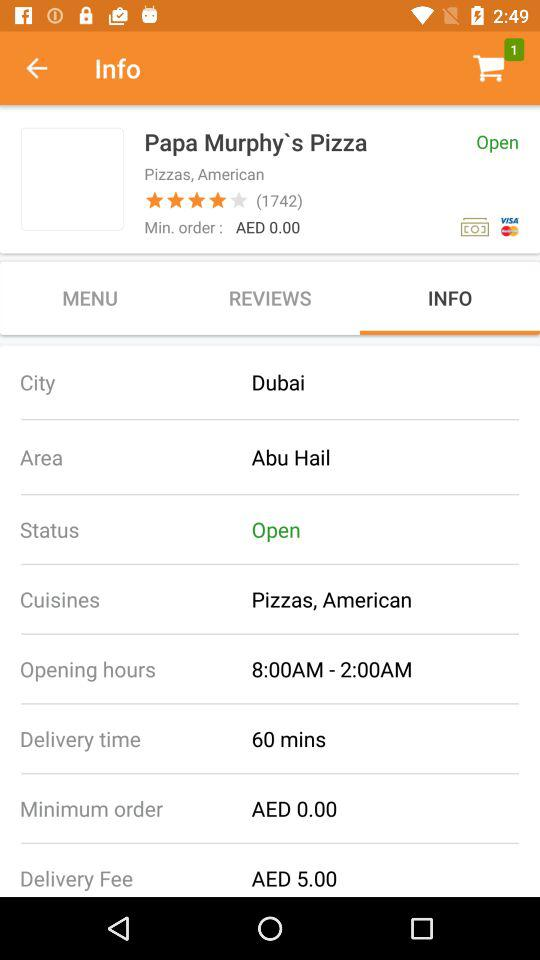What is the name of the city? The name of the city is Dubai. 